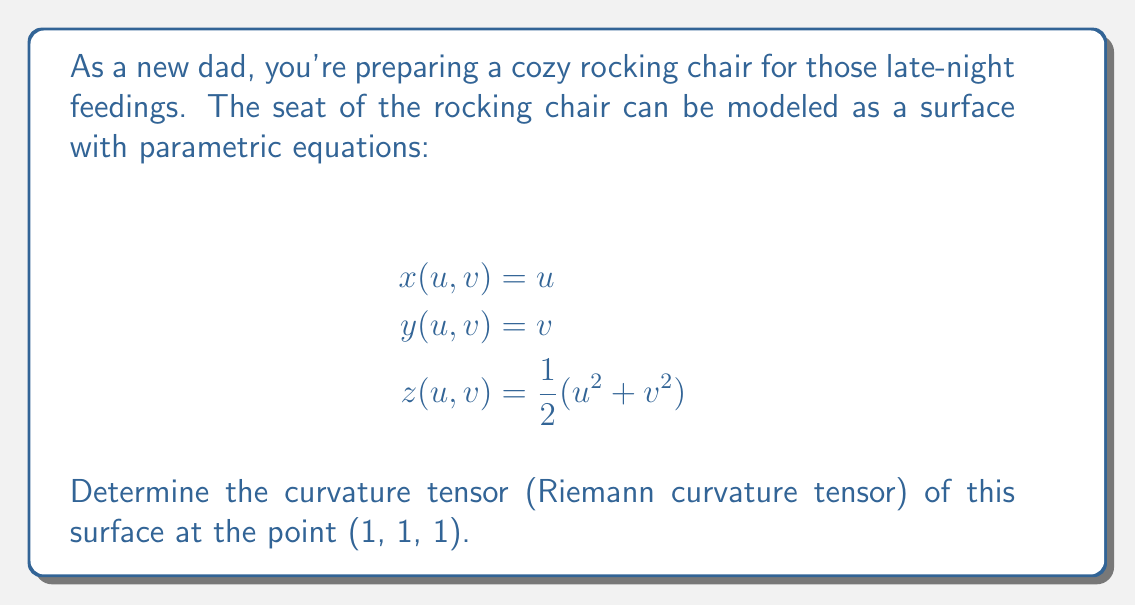Show me your answer to this math problem. To find the curvature tensor, we'll follow these steps:

1) First, we need to calculate the metric tensor $g_{ij}$:
   $$g_{11} = 1 + u^2$$
   $$g_{12} = g_{21} = uv$$
   $$g_{22} = 1 + v^2$$

2) Next, we calculate the Christoffel symbols:
   $$\Gamma^k_{ij} = \frac{1}{2}g^{kl}(\partial_i g_{jl} + \partial_j g_{il} - \partial_l g_{ij})$$

   The non-zero Christoffel symbols are:
   $$\Gamma^1_{11} = \frac{u}{1+u^2+v^2}$$
   $$\Gamma^1_{12} = \Gamma^1_{21} = -\frac{uv}{1+u^2+v^2}$$
   $$\Gamma^2_{12} = \Gamma^2_{21} = \frac{u}{1+u^2+v^2}$$
   $$\Gamma^2_{22} = \frac{v}{1+u^2+v^2}$$

3) Now we can calculate the Riemann curvature tensor:
   $$R^i_{jkl} = \partial_k \Gamma^i_{jl} - \partial_l \Gamma^i_{jk} + \Gamma^m_{jl}\Gamma^i_{mk} - \Gamma^m_{jk}\Gamma^i_{ml}$$

4) At the point (1, 1, 1), we get:
   $$R^1_{212} = -R^1_{221} = \frac{1}{3}$$
   $$R^2_{121} = -R^2_{112} = \frac{1}{3}$$

   All other components are zero at this point.

5) The Riemann curvature tensor in its fully covariant form is:
   $$R_{ijkl} = g_{im}R^m_{jkl}$$

   At (1, 1, 1), the non-zero components are:
   $$R_{1212} = R_{2121} = \frac{1}{3}$$
Answer: $R_{1212} = R_{2121} = \frac{1}{3}$, all other components zero 